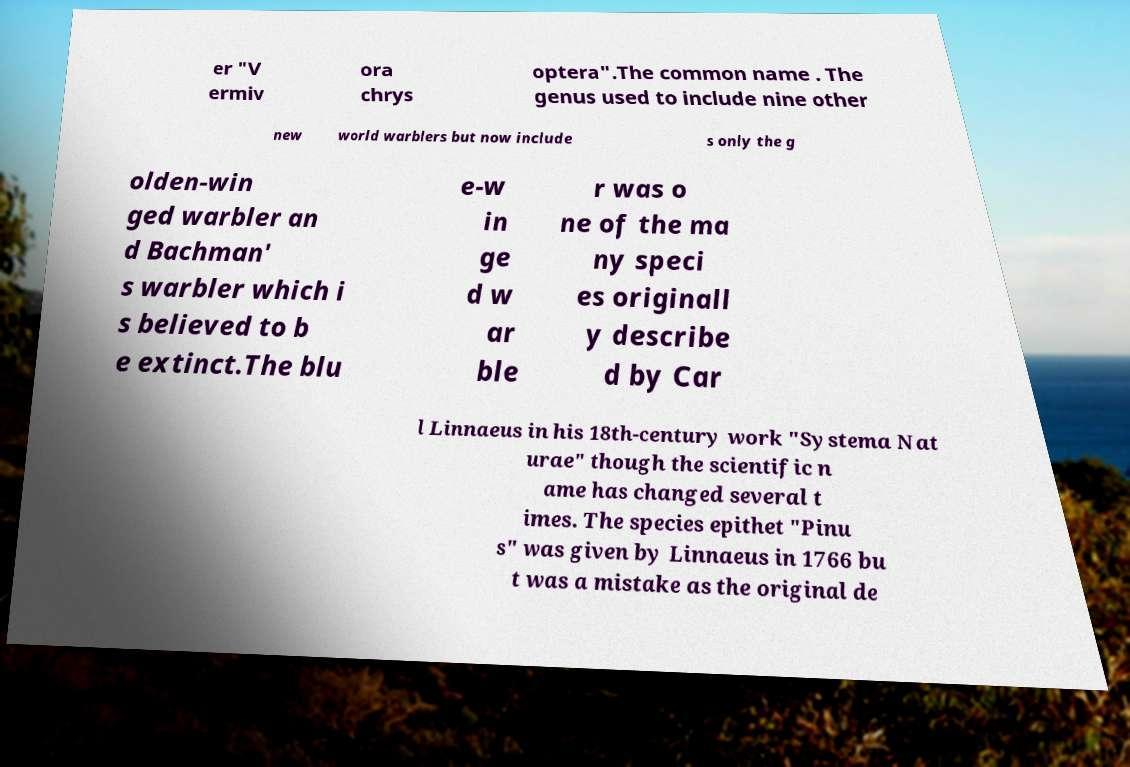What messages or text are displayed in this image? I need them in a readable, typed format. er "V ermiv ora chrys optera".The common name . The genus used to include nine other new world warblers but now include s only the g olden-win ged warbler an d Bachman' s warbler which i s believed to b e extinct.The blu e-w in ge d w ar ble r was o ne of the ma ny speci es originall y describe d by Car l Linnaeus in his 18th-century work "Systema Nat urae" though the scientific n ame has changed several t imes. The species epithet "Pinu s" was given by Linnaeus in 1766 bu t was a mistake as the original de 